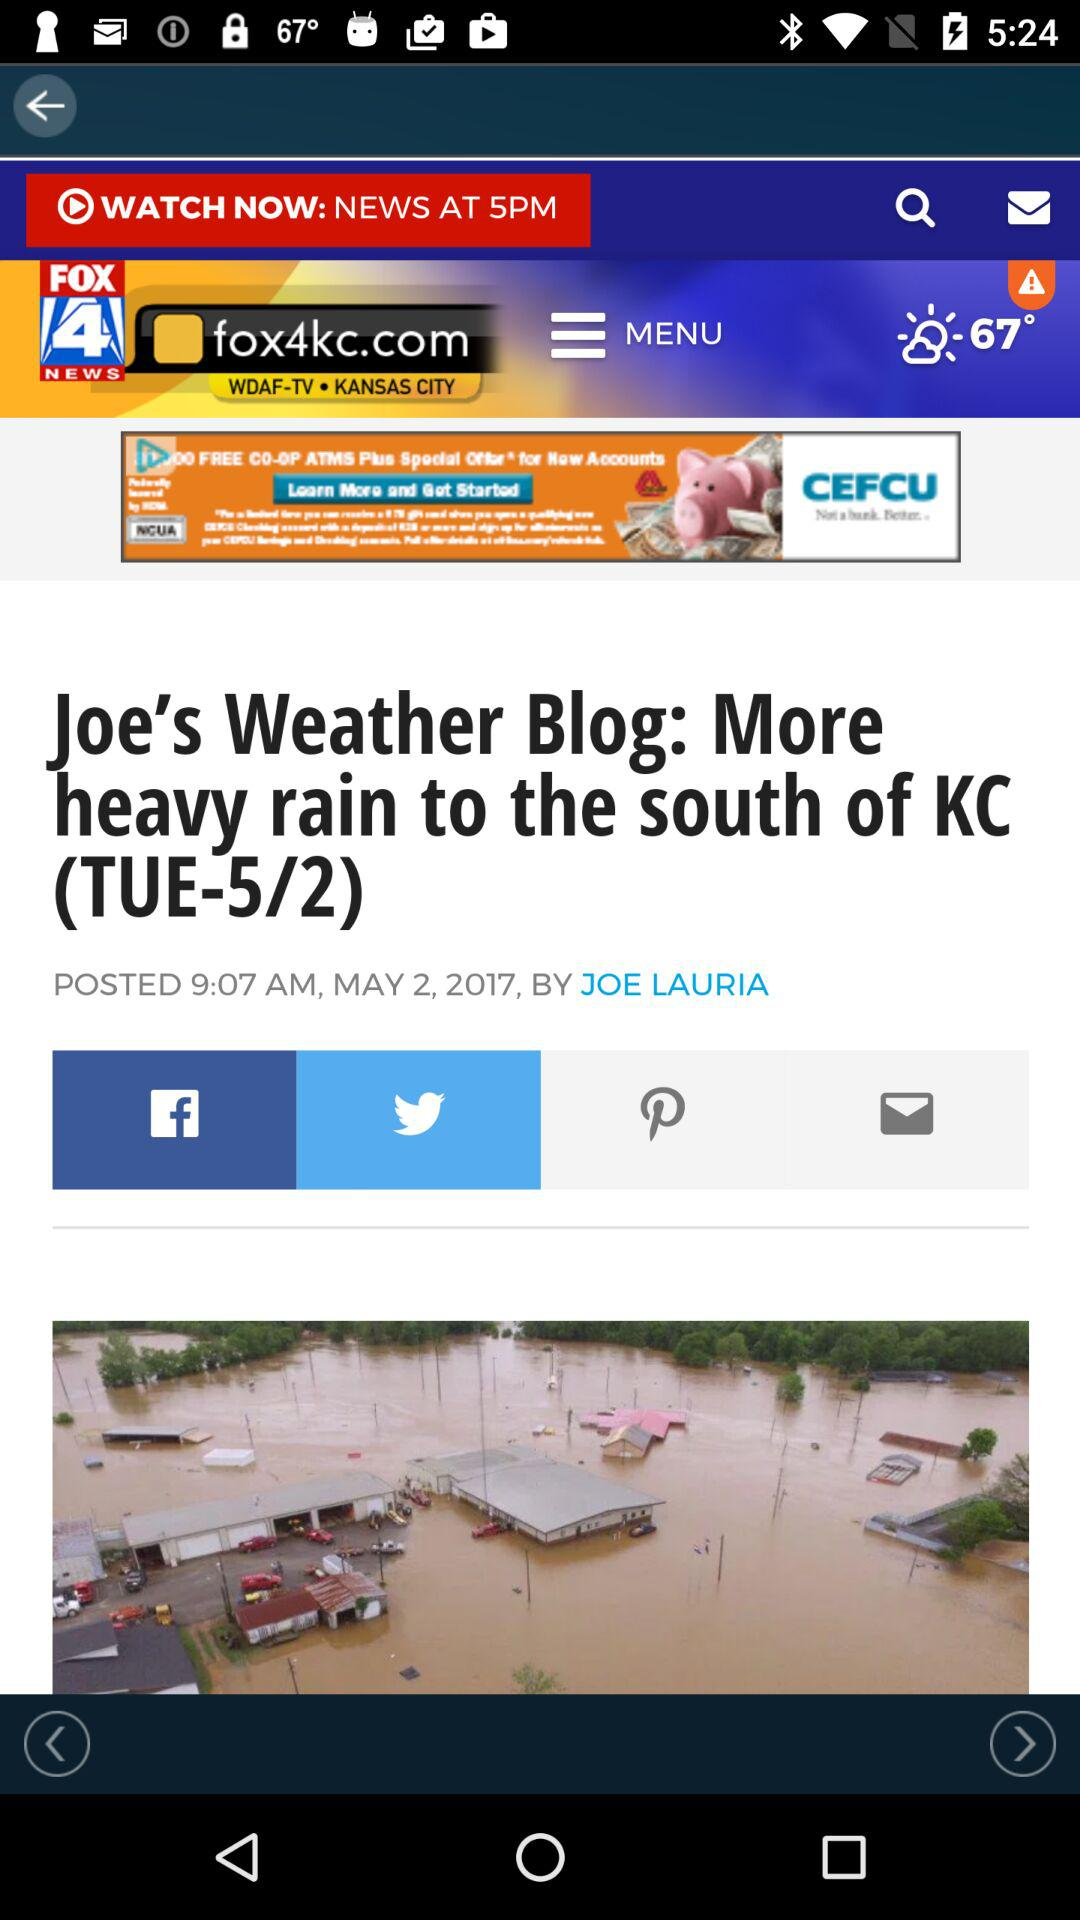When was the news posted? The news was posted on May 2, 2017 at 9:07 a.m. 